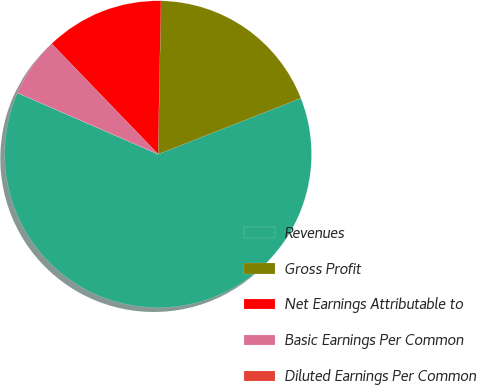<chart> <loc_0><loc_0><loc_500><loc_500><pie_chart><fcel>Revenues<fcel>Gross Profit<fcel>Net Earnings Attributable to<fcel>Basic Earnings Per Common<fcel>Diluted Earnings Per Common<nl><fcel>62.49%<fcel>18.75%<fcel>12.5%<fcel>6.25%<fcel>0.0%<nl></chart> 